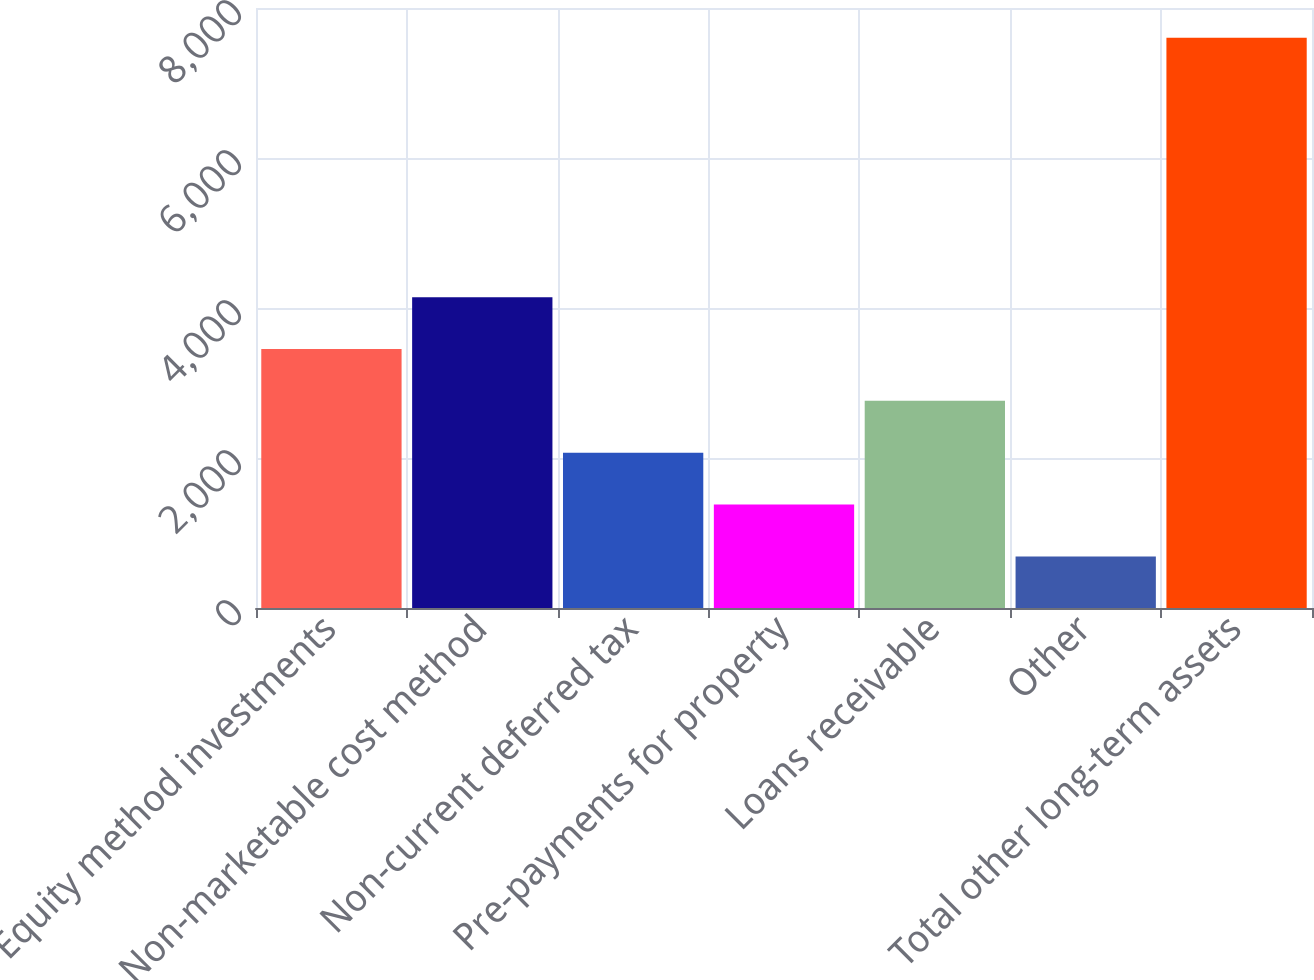Convert chart to OTSL. <chart><loc_0><loc_0><loc_500><loc_500><bar_chart><fcel>Equity method investments<fcel>Non-marketable cost method<fcel>Non-current deferred tax<fcel>Pre-payments for property<fcel>Loans receivable<fcel>Other<fcel>Total other long-term assets<nl><fcel>3453.6<fcel>4145<fcel>2070.8<fcel>1379.4<fcel>2762.2<fcel>688<fcel>7602<nl></chart> 